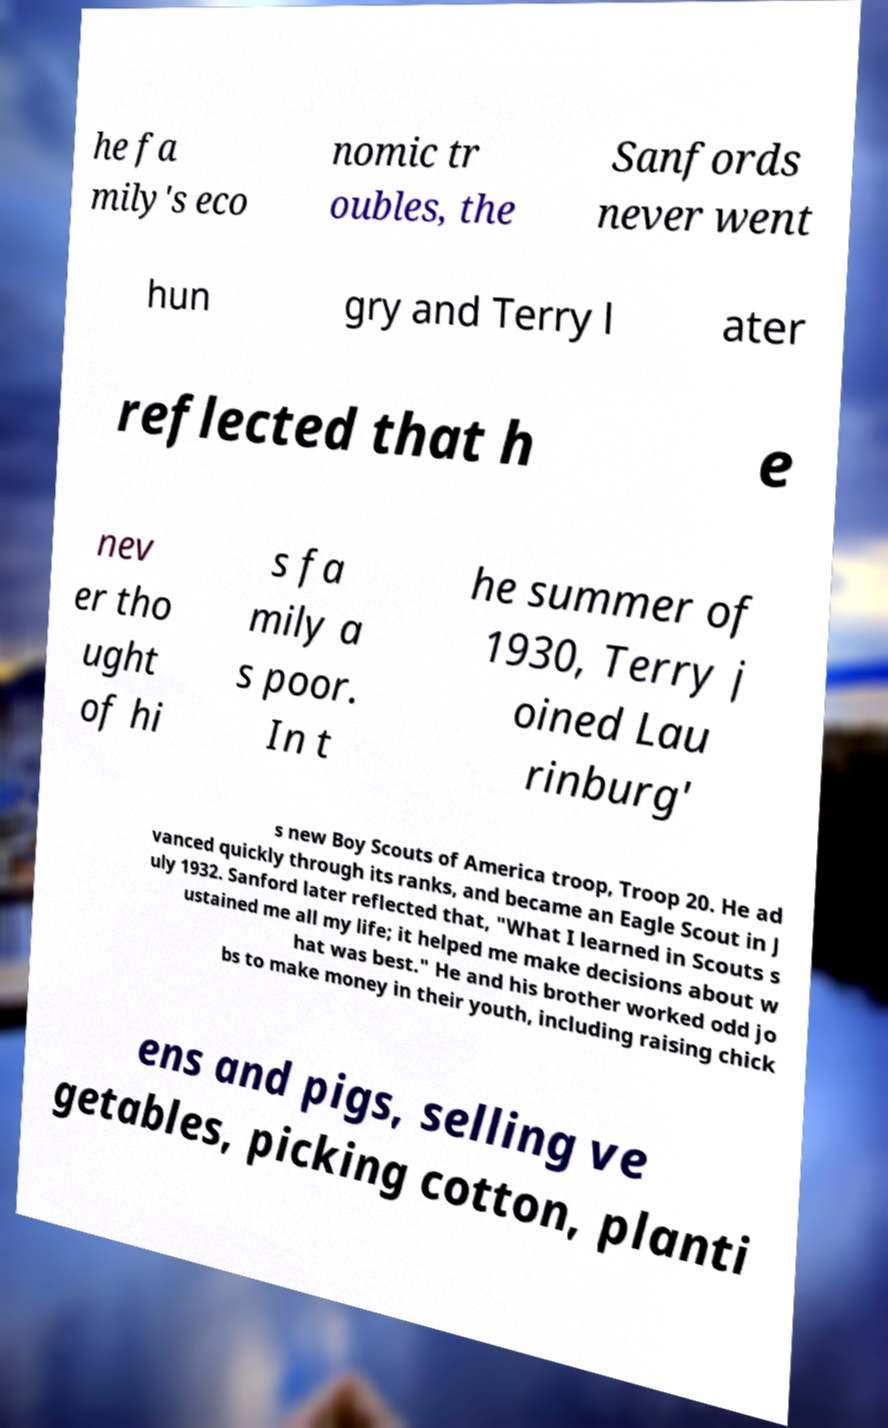Please read and relay the text visible in this image. What does it say? he fa mily's eco nomic tr oubles, the Sanfords never went hun gry and Terry l ater reflected that h e nev er tho ught of hi s fa mily a s poor. In t he summer of 1930, Terry j oined Lau rinburg' s new Boy Scouts of America troop, Troop 20. He ad vanced quickly through its ranks, and became an Eagle Scout in J uly 1932. Sanford later reflected that, "What I learned in Scouts s ustained me all my life; it helped me make decisions about w hat was best." He and his brother worked odd jo bs to make money in their youth, including raising chick ens and pigs, selling ve getables, picking cotton, planti 